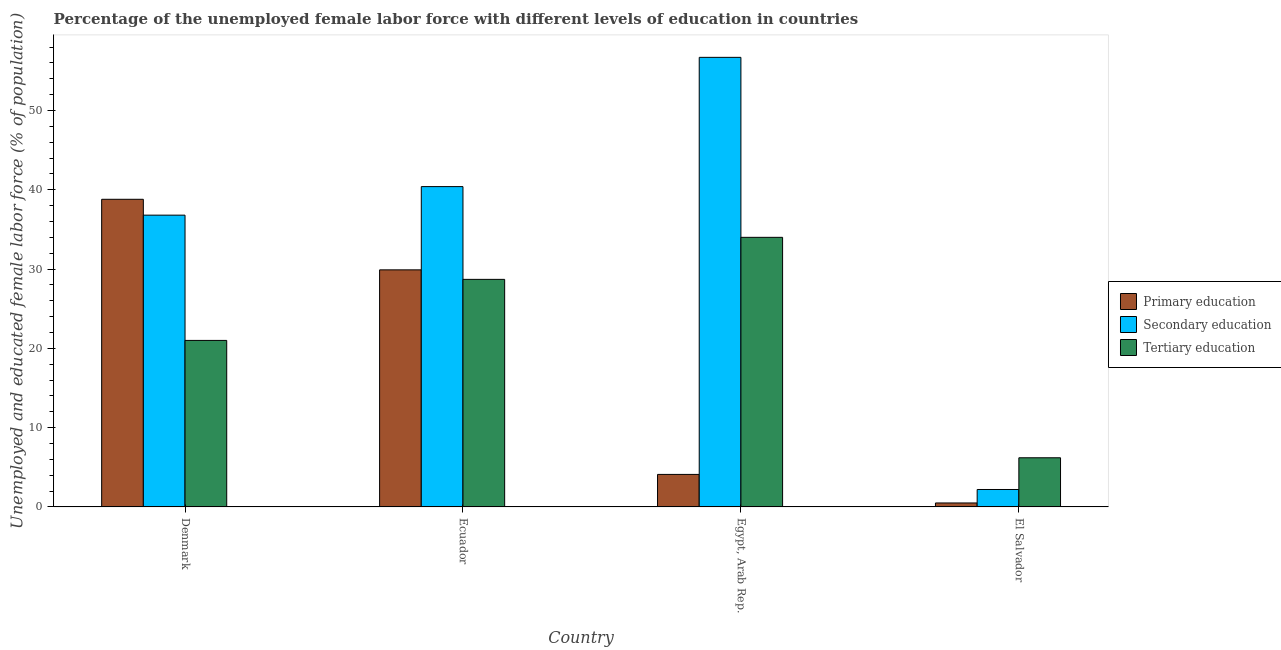How many different coloured bars are there?
Offer a very short reply. 3. Are the number of bars on each tick of the X-axis equal?
Make the answer very short. Yes. What is the label of the 4th group of bars from the left?
Offer a very short reply. El Salvador. In how many cases, is the number of bars for a given country not equal to the number of legend labels?
Provide a short and direct response. 0. Across all countries, what is the maximum percentage of female labor force who received primary education?
Ensure brevity in your answer.  38.8. Across all countries, what is the minimum percentage of female labor force who received tertiary education?
Ensure brevity in your answer.  6.2. In which country was the percentage of female labor force who received tertiary education maximum?
Your response must be concise. Egypt, Arab Rep. In which country was the percentage of female labor force who received secondary education minimum?
Provide a short and direct response. El Salvador. What is the total percentage of female labor force who received tertiary education in the graph?
Provide a short and direct response. 89.9. What is the difference between the percentage of female labor force who received tertiary education in Ecuador and that in Egypt, Arab Rep.?
Provide a short and direct response. -5.3. What is the difference between the percentage of female labor force who received primary education in Ecuador and the percentage of female labor force who received tertiary education in Egypt, Arab Rep.?
Offer a very short reply. -4.1. What is the average percentage of female labor force who received secondary education per country?
Provide a succinct answer. 34.03. What is the difference between the percentage of female labor force who received primary education and percentage of female labor force who received secondary education in Egypt, Arab Rep.?
Provide a short and direct response. -52.6. In how many countries, is the percentage of female labor force who received tertiary education greater than 34 %?
Make the answer very short. 0. What is the ratio of the percentage of female labor force who received tertiary education in Ecuador to that in El Salvador?
Your answer should be compact. 4.63. Is the percentage of female labor force who received tertiary education in Ecuador less than that in Egypt, Arab Rep.?
Give a very brief answer. Yes. What is the difference between the highest and the second highest percentage of female labor force who received tertiary education?
Your response must be concise. 5.3. What is the difference between the highest and the lowest percentage of female labor force who received secondary education?
Give a very brief answer. 54.5. In how many countries, is the percentage of female labor force who received primary education greater than the average percentage of female labor force who received primary education taken over all countries?
Your response must be concise. 2. What does the 2nd bar from the left in El Salvador represents?
Provide a short and direct response. Secondary education. What does the 2nd bar from the right in Ecuador represents?
Your answer should be very brief. Secondary education. Is it the case that in every country, the sum of the percentage of female labor force who received primary education and percentage of female labor force who received secondary education is greater than the percentage of female labor force who received tertiary education?
Your response must be concise. No. How many bars are there?
Your answer should be compact. 12. Are all the bars in the graph horizontal?
Give a very brief answer. No. How many countries are there in the graph?
Give a very brief answer. 4. Are the values on the major ticks of Y-axis written in scientific E-notation?
Your answer should be very brief. No. Does the graph contain any zero values?
Make the answer very short. No. Does the graph contain grids?
Provide a succinct answer. No. Where does the legend appear in the graph?
Provide a short and direct response. Center right. How many legend labels are there?
Your answer should be very brief. 3. How are the legend labels stacked?
Offer a very short reply. Vertical. What is the title of the graph?
Provide a short and direct response. Percentage of the unemployed female labor force with different levels of education in countries. Does "Financial account" appear as one of the legend labels in the graph?
Ensure brevity in your answer.  No. What is the label or title of the X-axis?
Your answer should be very brief. Country. What is the label or title of the Y-axis?
Give a very brief answer. Unemployed and educated female labor force (% of population). What is the Unemployed and educated female labor force (% of population) of Primary education in Denmark?
Offer a terse response. 38.8. What is the Unemployed and educated female labor force (% of population) in Secondary education in Denmark?
Your response must be concise. 36.8. What is the Unemployed and educated female labor force (% of population) of Primary education in Ecuador?
Your response must be concise. 29.9. What is the Unemployed and educated female labor force (% of population) of Secondary education in Ecuador?
Your response must be concise. 40.4. What is the Unemployed and educated female labor force (% of population) in Tertiary education in Ecuador?
Keep it short and to the point. 28.7. What is the Unemployed and educated female labor force (% of population) in Primary education in Egypt, Arab Rep.?
Make the answer very short. 4.1. What is the Unemployed and educated female labor force (% of population) in Secondary education in Egypt, Arab Rep.?
Offer a terse response. 56.7. What is the Unemployed and educated female labor force (% of population) of Secondary education in El Salvador?
Offer a terse response. 2.2. What is the Unemployed and educated female labor force (% of population) of Tertiary education in El Salvador?
Your response must be concise. 6.2. Across all countries, what is the maximum Unemployed and educated female labor force (% of population) in Primary education?
Make the answer very short. 38.8. Across all countries, what is the maximum Unemployed and educated female labor force (% of population) in Secondary education?
Provide a short and direct response. 56.7. Across all countries, what is the minimum Unemployed and educated female labor force (% of population) in Primary education?
Give a very brief answer. 0.5. Across all countries, what is the minimum Unemployed and educated female labor force (% of population) of Secondary education?
Provide a short and direct response. 2.2. Across all countries, what is the minimum Unemployed and educated female labor force (% of population) of Tertiary education?
Provide a succinct answer. 6.2. What is the total Unemployed and educated female labor force (% of population) in Primary education in the graph?
Make the answer very short. 73.3. What is the total Unemployed and educated female labor force (% of population) of Secondary education in the graph?
Provide a short and direct response. 136.1. What is the total Unemployed and educated female labor force (% of population) of Tertiary education in the graph?
Give a very brief answer. 89.9. What is the difference between the Unemployed and educated female labor force (% of population) of Primary education in Denmark and that in Egypt, Arab Rep.?
Your response must be concise. 34.7. What is the difference between the Unemployed and educated female labor force (% of population) of Secondary education in Denmark and that in Egypt, Arab Rep.?
Your answer should be very brief. -19.9. What is the difference between the Unemployed and educated female labor force (% of population) in Primary education in Denmark and that in El Salvador?
Your response must be concise. 38.3. What is the difference between the Unemployed and educated female labor force (% of population) in Secondary education in Denmark and that in El Salvador?
Your answer should be compact. 34.6. What is the difference between the Unemployed and educated female labor force (% of population) of Primary education in Ecuador and that in Egypt, Arab Rep.?
Offer a terse response. 25.8. What is the difference between the Unemployed and educated female labor force (% of population) in Secondary education in Ecuador and that in Egypt, Arab Rep.?
Provide a short and direct response. -16.3. What is the difference between the Unemployed and educated female labor force (% of population) of Tertiary education in Ecuador and that in Egypt, Arab Rep.?
Ensure brevity in your answer.  -5.3. What is the difference between the Unemployed and educated female labor force (% of population) of Primary education in Ecuador and that in El Salvador?
Your response must be concise. 29.4. What is the difference between the Unemployed and educated female labor force (% of population) of Secondary education in Ecuador and that in El Salvador?
Provide a short and direct response. 38.2. What is the difference between the Unemployed and educated female labor force (% of population) in Tertiary education in Ecuador and that in El Salvador?
Offer a terse response. 22.5. What is the difference between the Unemployed and educated female labor force (% of population) of Primary education in Egypt, Arab Rep. and that in El Salvador?
Your answer should be very brief. 3.6. What is the difference between the Unemployed and educated female labor force (% of population) of Secondary education in Egypt, Arab Rep. and that in El Salvador?
Offer a terse response. 54.5. What is the difference between the Unemployed and educated female labor force (% of population) in Tertiary education in Egypt, Arab Rep. and that in El Salvador?
Keep it short and to the point. 27.8. What is the difference between the Unemployed and educated female labor force (% of population) of Primary education in Denmark and the Unemployed and educated female labor force (% of population) of Secondary education in Egypt, Arab Rep.?
Your response must be concise. -17.9. What is the difference between the Unemployed and educated female labor force (% of population) in Primary education in Denmark and the Unemployed and educated female labor force (% of population) in Tertiary education in Egypt, Arab Rep.?
Keep it short and to the point. 4.8. What is the difference between the Unemployed and educated female labor force (% of population) in Primary education in Denmark and the Unemployed and educated female labor force (% of population) in Secondary education in El Salvador?
Provide a short and direct response. 36.6. What is the difference between the Unemployed and educated female labor force (% of population) in Primary education in Denmark and the Unemployed and educated female labor force (% of population) in Tertiary education in El Salvador?
Your response must be concise. 32.6. What is the difference between the Unemployed and educated female labor force (% of population) of Secondary education in Denmark and the Unemployed and educated female labor force (% of population) of Tertiary education in El Salvador?
Provide a succinct answer. 30.6. What is the difference between the Unemployed and educated female labor force (% of population) of Primary education in Ecuador and the Unemployed and educated female labor force (% of population) of Secondary education in Egypt, Arab Rep.?
Offer a very short reply. -26.8. What is the difference between the Unemployed and educated female labor force (% of population) in Primary education in Ecuador and the Unemployed and educated female labor force (% of population) in Tertiary education in Egypt, Arab Rep.?
Your answer should be compact. -4.1. What is the difference between the Unemployed and educated female labor force (% of population) in Primary education in Ecuador and the Unemployed and educated female labor force (% of population) in Secondary education in El Salvador?
Keep it short and to the point. 27.7. What is the difference between the Unemployed and educated female labor force (% of population) of Primary education in Ecuador and the Unemployed and educated female labor force (% of population) of Tertiary education in El Salvador?
Give a very brief answer. 23.7. What is the difference between the Unemployed and educated female labor force (% of population) of Secondary education in Ecuador and the Unemployed and educated female labor force (% of population) of Tertiary education in El Salvador?
Provide a succinct answer. 34.2. What is the difference between the Unemployed and educated female labor force (% of population) in Primary education in Egypt, Arab Rep. and the Unemployed and educated female labor force (% of population) in Tertiary education in El Salvador?
Offer a very short reply. -2.1. What is the difference between the Unemployed and educated female labor force (% of population) of Secondary education in Egypt, Arab Rep. and the Unemployed and educated female labor force (% of population) of Tertiary education in El Salvador?
Your answer should be compact. 50.5. What is the average Unemployed and educated female labor force (% of population) in Primary education per country?
Your response must be concise. 18.32. What is the average Unemployed and educated female labor force (% of population) in Secondary education per country?
Offer a terse response. 34.02. What is the average Unemployed and educated female labor force (% of population) in Tertiary education per country?
Ensure brevity in your answer.  22.48. What is the difference between the Unemployed and educated female labor force (% of population) of Primary education and Unemployed and educated female labor force (% of population) of Secondary education in Denmark?
Provide a succinct answer. 2. What is the difference between the Unemployed and educated female labor force (% of population) in Secondary education and Unemployed and educated female labor force (% of population) in Tertiary education in Denmark?
Keep it short and to the point. 15.8. What is the difference between the Unemployed and educated female labor force (% of population) of Primary education and Unemployed and educated female labor force (% of population) of Secondary education in Egypt, Arab Rep.?
Ensure brevity in your answer.  -52.6. What is the difference between the Unemployed and educated female labor force (% of population) in Primary education and Unemployed and educated female labor force (% of population) in Tertiary education in Egypt, Arab Rep.?
Offer a very short reply. -29.9. What is the difference between the Unemployed and educated female labor force (% of population) in Secondary education and Unemployed and educated female labor force (% of population) in Tertiary education in Egypt, Arab Rep.?
Make the answer very short. 22.7. What is the difference between the Unemployed and educated female labor force (% of population) in Primary education and Unemployed and educated female labor force (% of population) in Secondary education in El Salvador?
Offer a terse response. -1.7. What is the difference between the Unemployed and educated female labor force (% of population) of Primary education and Unemployed and educated female labor force (% of population) of Tertiary education in El Salvador?
Provide a short and direct response. -5.7. What is the ratio of the Unemployed and educated female labor force (% of population) in Primary education in Denmark to that in Ecuador?
Provide a succinct answer. 1.3. What is the ratio of the Unemployed and educated female labor force (% of population) of Secondary education in Denmark to that in Ecuador?
Offer a terse response. 0.91. What is the ratio of the Unemployed and educated female labor force (% of population) in Tertiary education in Denmark to that in Ecuador?
Provide a short and direct response. 0.73. What is the ratio of the Unemployed and educated female labor force (% of population) in Primary education in Denmark to that in Egypt, Arab Rep.?
Provide a short and direct response. 9.46. What is the ratio of the Unemployed and educated female labor force (% of population) of Secondary education in Denmark to that in Egypt, Arab Rep.?
Give a very brief answer. 0.65. What is the ratio of the Unemployed and educated female labor force (% of population) of Tertiary education in Denmark to that in Egypt, Arab Rep.?
Offer a terse response. 0.62. What is the ratio of the Unemployed and educated female labor force (% of population) of Primary education in Denmark to that in El Salvador?
Ensure brevity in your answer.  77.6. What is the ratio of the Unemployed and educated female labor force (% of population) in Secondary education in Denmark to that in El Salvador?
Ensure brevity in your answer.  16.73. What is the ratio of the Unemployed and educated female labor force (% of population) in Tertiary education in Denmark to that in El Salvador?
Provide a short and direct response. 3.39. What is the ratio of the Unemployed and educated female labor force (% of population) in Primary education in Ecuador to that in Egypt, Arab Rep.?
Provide a succinct answer. 7.29. What is the ratio of the Unemployed and educated female labor force (% of population) of Secondary education in Ecuador to that in Egypt, Arab Rep.?
Give a very brief answer. 0.71. What is the ratio of the Unemployed and educated female labor force (% of population) of Tertiary education in Ecuador to that in Egypt, Arab Rep.?
Your response must be concise. 0.84. What is the ratio of the Unemployed and educated female labor force (% of population) of Primary education in Ecuador to that in El Salvador?
Provide a short and direct response. 59.8. What is the ratio of the Unemployed and educated female labor force (% of population) of Secondary education in Ecuador to that in El Salvador?
Make the answer very short. 18.36. What is the ratio of the Unemployed and educated female labor force (% of population) of Tertiary education in Ecuador to that in El Salvador?
Ensure brevity in your answer.  4.63. What is the ratio of the Unemployed and educated female labor force (% of population) in Secondary education in Egypt, Arab Rep. to that in El Salvador?
Offer a terse response. 25.77. What is the ratio of the Unemployed and educated female labor force (% of population) of Tertiary education in Egypt, Arab Rep. to that in El Salvador?
Keep it short and to the point. 5.48. What is the difference between the highest and the second highest Unemployed and educated female labor force (% of population) of Primary education?
Your answer should be compact. 8.9. What is the difference between the highest and the second highest Unemployed and educated female labor force (% of population) in Secondary education?
Offer a terse response. 16.3. What is the difference between the highest and the lowest Unemployed and educated female labor force (% of population) of Primary education?
Give a very brief answer. 38.3. What is the difference between the highest and the lowest Unemployed and educated female labor force (% of population) of Secondary education?
Provide a short and direct response. 54.5. What is the difference between the highest and the lowest Unemployed and educated female labor force (% of population) of Tertiary education?
Offer a very short reply. 27.8. 